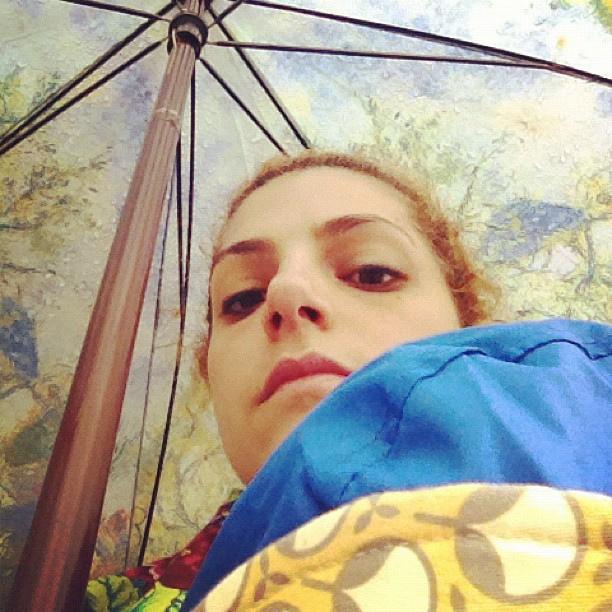What is above the woman's head?
Give a very brief answer. Umbrella. Does the girl look serious?
Quick response, please. Yes. Is she wearing a jacket?
Concise answer only. Yes. 